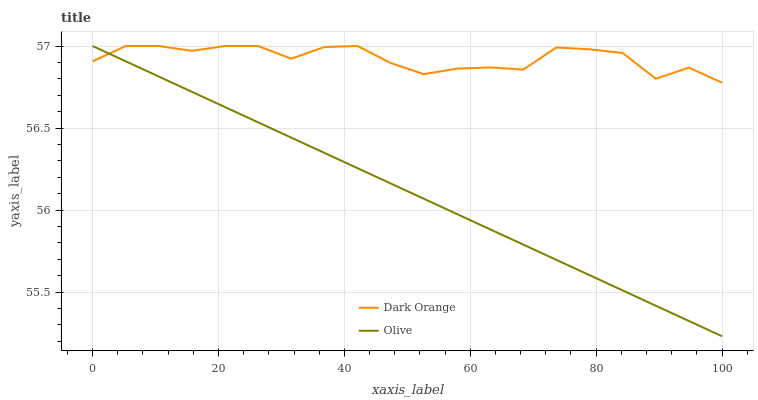Does Olive have the minimum area under the curve?
Answer yes or no. Yes. Does Dark Orange have the maximum area under the curve?
Answer yes or no. Yes. Does Dark Orange have the minimum area under the curve?
Answer yes or no. No. Is Olive the smoothest?
Answer yes or no. Yes. Is Dark Orange the roughest?
Answer yes or no. Yes. Is Dark Orange the smoothest?
Answer yes or no. No. Does Olive have the lowest value?
Answer yes or no. Yes. Does Dark Orange have the lowest value?
Answer yes or no. No. Does Dark Orange have the highest value?
Answer yes or no. Yes. Does Olive intersect Dark Orange?
Answer yes or no. Yes. Is Olive less than Dark Orange?
Answer yes or no. No. Is Olive greater than Dark Orange?
Answer yes or no. No. 